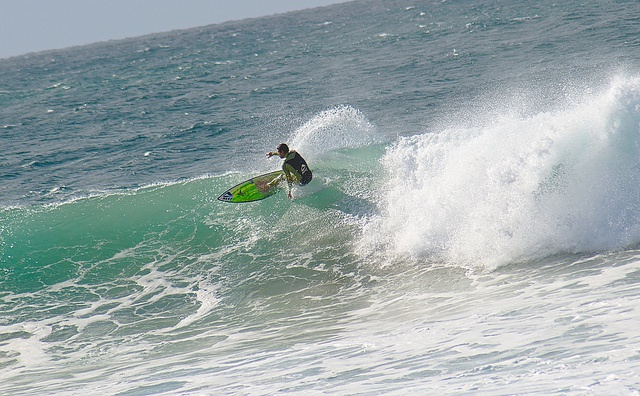Describe the objects in this image and their specific colors. I can see surfboard in darkgray, gray, green, and darkgreen tones and people in darkgray, black, gray, and darkgreen tones in this image. 